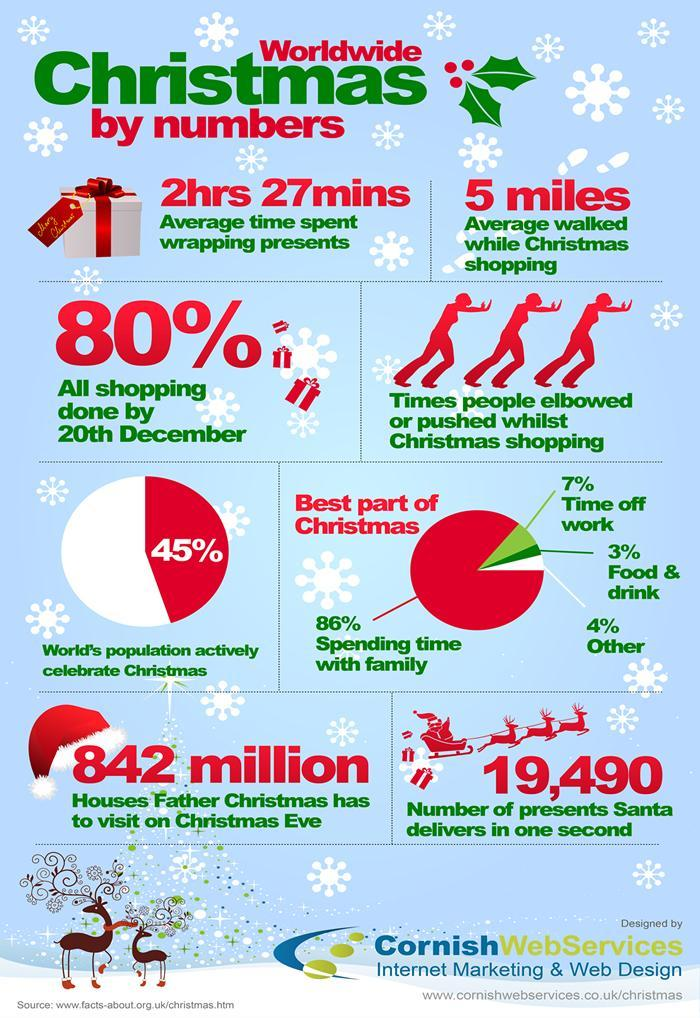What percent of world population do not celebrate Christmas?
Answer the question with a short phrase. 55% How many times people elbowed or pushed whilst Christmas shopping? 3 What is the best part of Christmas according to the majority? Spending time with family 